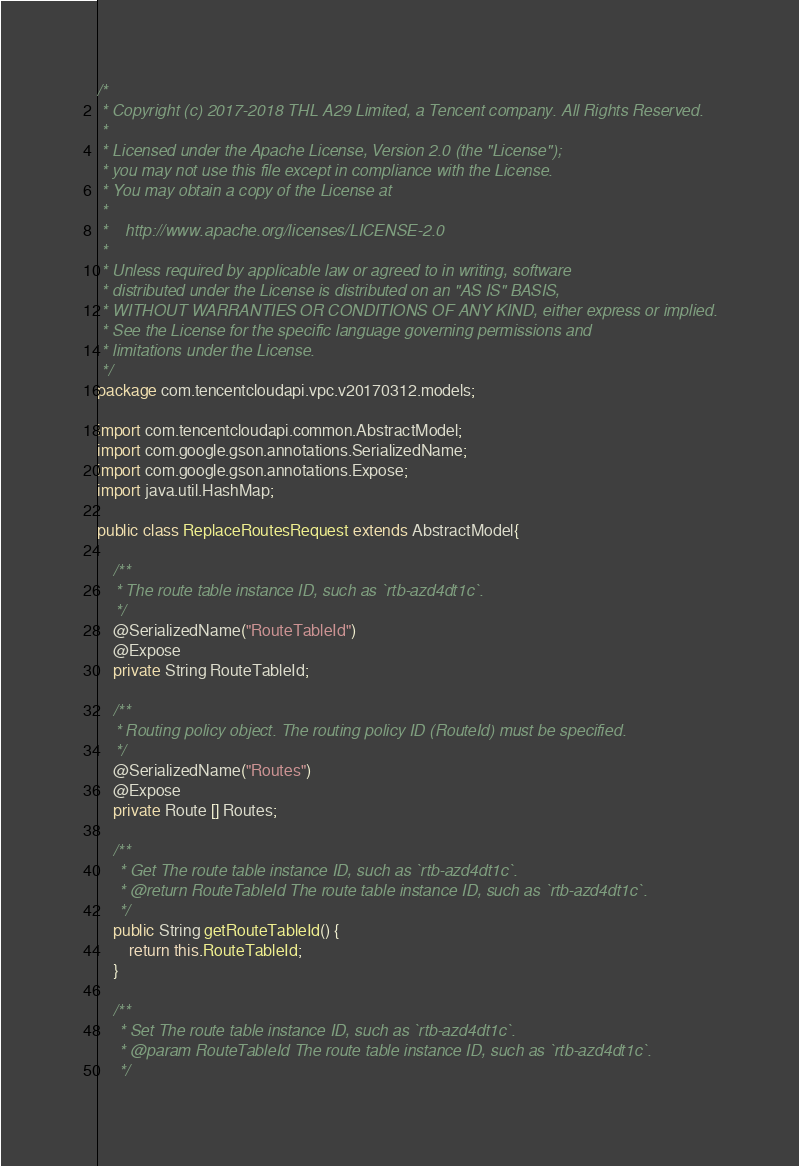<code> <loc_0><loc_0><loc_500><loc_500><_Java_>/*
 * Copyright (c) 2017-2018 THL A29 Limited, a Tencent company. All Rights Reserved.
 *
 * Licensed under the Apache License, Version 2.0 (the "License");
 * you may not use this file except in compliance with the License.
 * You may obtain a copy of the License at
 *
 *    http://www.apache.org/licenses/LICENSE-2.0
 *
 * Unless required by applicable law or agreed to in writing, software
 * distributed under the License is distributed on an "AS IS" BASIS,
 * WITHOUT WARRANTIES OR CONDITIONS OF ANY KIND, either express or implied.
 * See the License for the specific language governing permissions and
 * limitations under the License.
 */
package com.tencentcloudapi.vpc.v20170312.models;

import com.tencentcloudapi.common.AbstractModel;
import com.google.gson.annotations.SerializedName;
import com.google.gson.annotations.Expose;
import java.util.HashMap;

public class ReplaceRoutesRequest extends AbstractModel{

    /**
    * The route table instance ID, such as `rtb-azd4dt1c`.
    */
    @SerializedName("RouteTableId")
    @Expose
    private String RouteTableId;

    /**
    * Routing policy object. The routing policy ID (RouteId) must be specified.
    */
    @SerializedName("Routes")
    @Expose
    private Route [] Routes;

    /**
     * Get The route table instance ID, such as `rtb-azd4dt1c`. 
     * @return RouteTableId The route table instance ID, such as `rtb-azd4dt1c`.
     */
    public String getRouteTableId() {
        return this.RouteTableId;
    }

    /**
     * Set The route table instance ID, such as `rtb-azd4dt1c`.
     * @param RouteTableId The route table instance ID, such as `rtb-azd4dt1c`.
     */</code> 